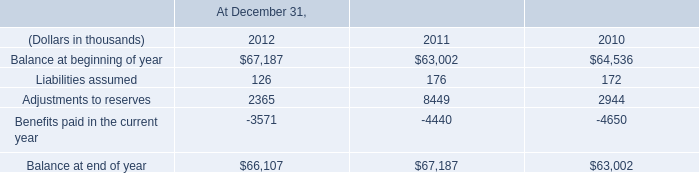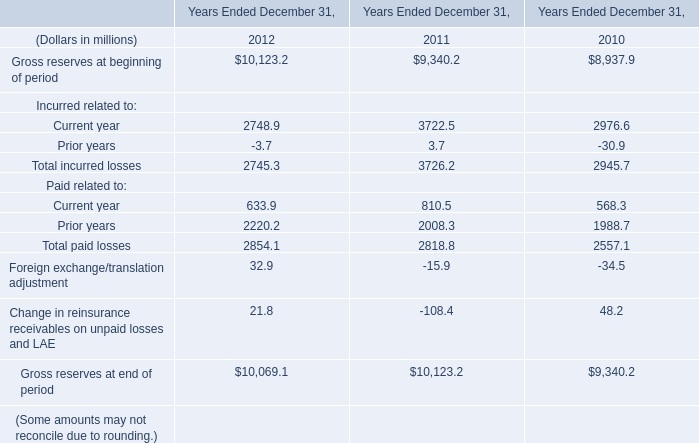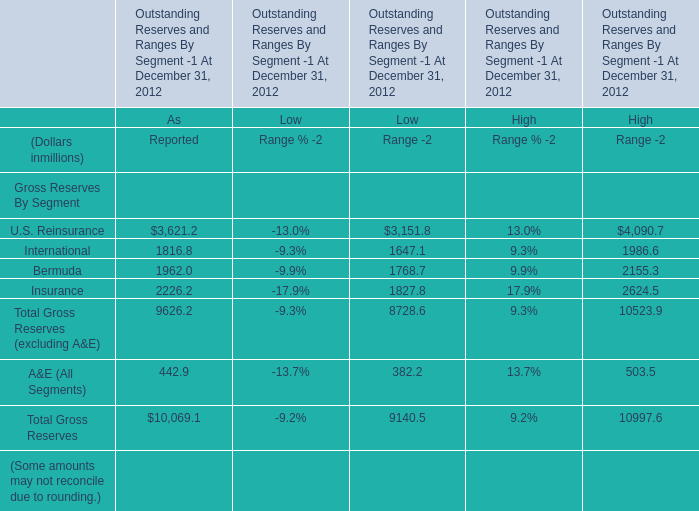What's the total value of all elements that are smaller than 2000 for for As Reported? (in million) 
Computations: ((1816.8 + 1962) + 442.9)
Answer: 4221.7. 